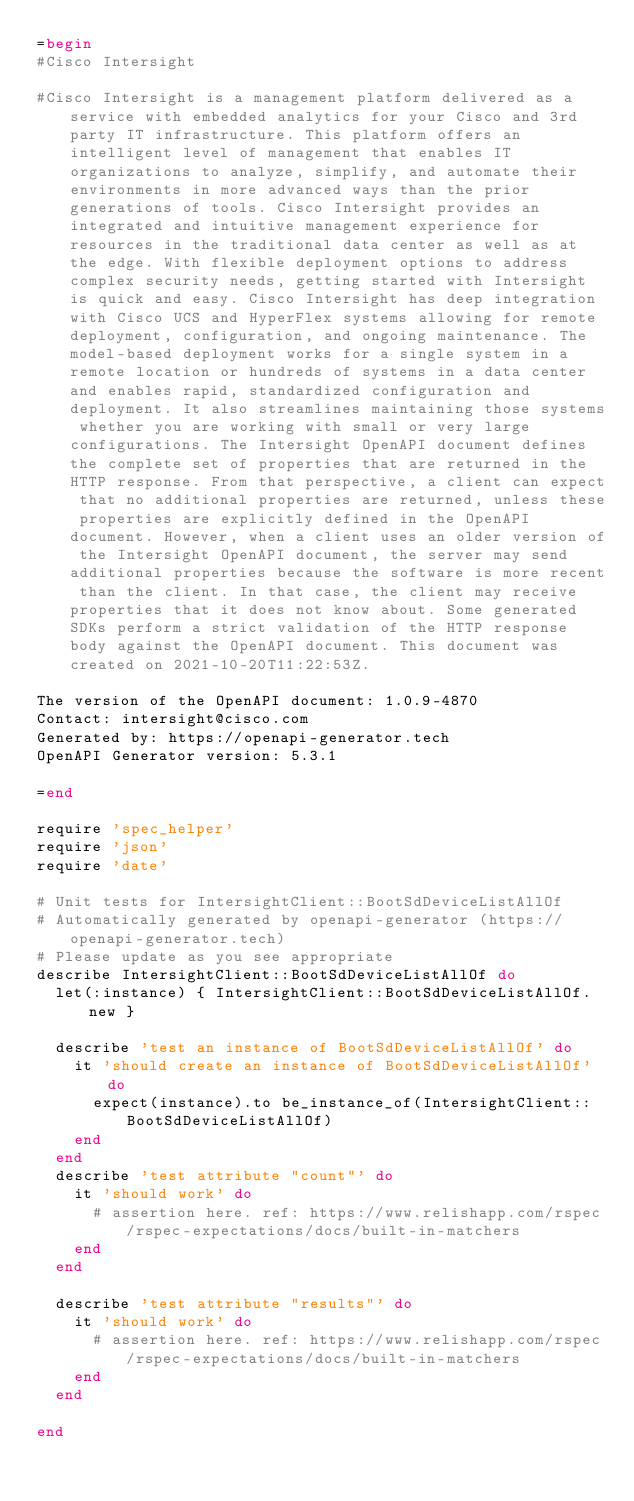<code> <loc_0><loc_0><loc_500><loc_500><_Ruby_>=begin
#Cisco Intersight

#Cisco Intersight is a management platform delivered as a service with embedded analytics for your Cisco and 3rd party IT infrastructure. This platform offers an intelligent level of management that enables IT organizations to analyze, simplify, and automate their environments in more advanced ways than the prior generations of tools. Cisco Intersight provides an integrated and intuitive management experience for resources in the traditional data center as well as at the edge. With flexible deployment options to address complex security needs, getting started with Intersight is quick and easy. Cisco Intersight has deep integration with Cisco UCS and HyperFlex systems allowing for remote deployment, configuration, and ongoing maintenance. The model-based deployment works for a single system in a remote location or hundreds of systems in a data center and enables rapid, standardized configuration and deployment. It also streamlines maintaining those systems whether you are working with small or very large configurations. The Intersight OpenAPI document defines the complete set of properties that are returned in the HTTP response. From that perspective, a client can expect that no additional properties are returned, unless these properties are explicitly defined in the OpenAPI document. However, when a client uses an older version of the Intersight OpenAPI document, the server may send additional properties because the software is more recent than the client. In that case, the client may receive properties that it does not know about. Some generated SDKs perform a strict validation of the HTTP response body against the OpenAPI document. This document was created on 2021-10-20T11:22:53Z.

The version of the OpenAPI document: 1.0.9-4870
Contact: intersight@cisco.com
Generated by: https://openapi-generator.tech
OpenAPI Generator version: 5.3.1

=end

require 'spec_helper'
require 'json'
require 'date'

# Unit tests for IntersightClient::BootSdDeviceListAllOf
# Automatically generated by openapi-generator (https://openapi-generator.tech)
# Please update as you see appropriate
describe IntersightClient::BootSdDeviceListAllOf do
  let(:instance) { IntersightClient::BootSdDeviceListAllOf.new }

  describe 'test an instance of BootSdDeviceListAllOf' do
    it 'should create an instance of BootSdDeviceListAllOf' do
      expect(instance).to be_instance_of(IntersightClient::BootSdDeviceListAllOf)
    end
  end
  describe 'test attribute "count"' do
    it 'should work' do
      # assertion here. ref: https://www.relishapp.com/rspec/rspec-expectations/docs/built-in-matchers
    end
  end

  describe 'test attribute "results"' do
    it 'should work' do
      # assertion here. ref: https://www.relishapp.com/rspec/rspec-expectations/docs/built-in-matchers
    end
  end

end
</code> 